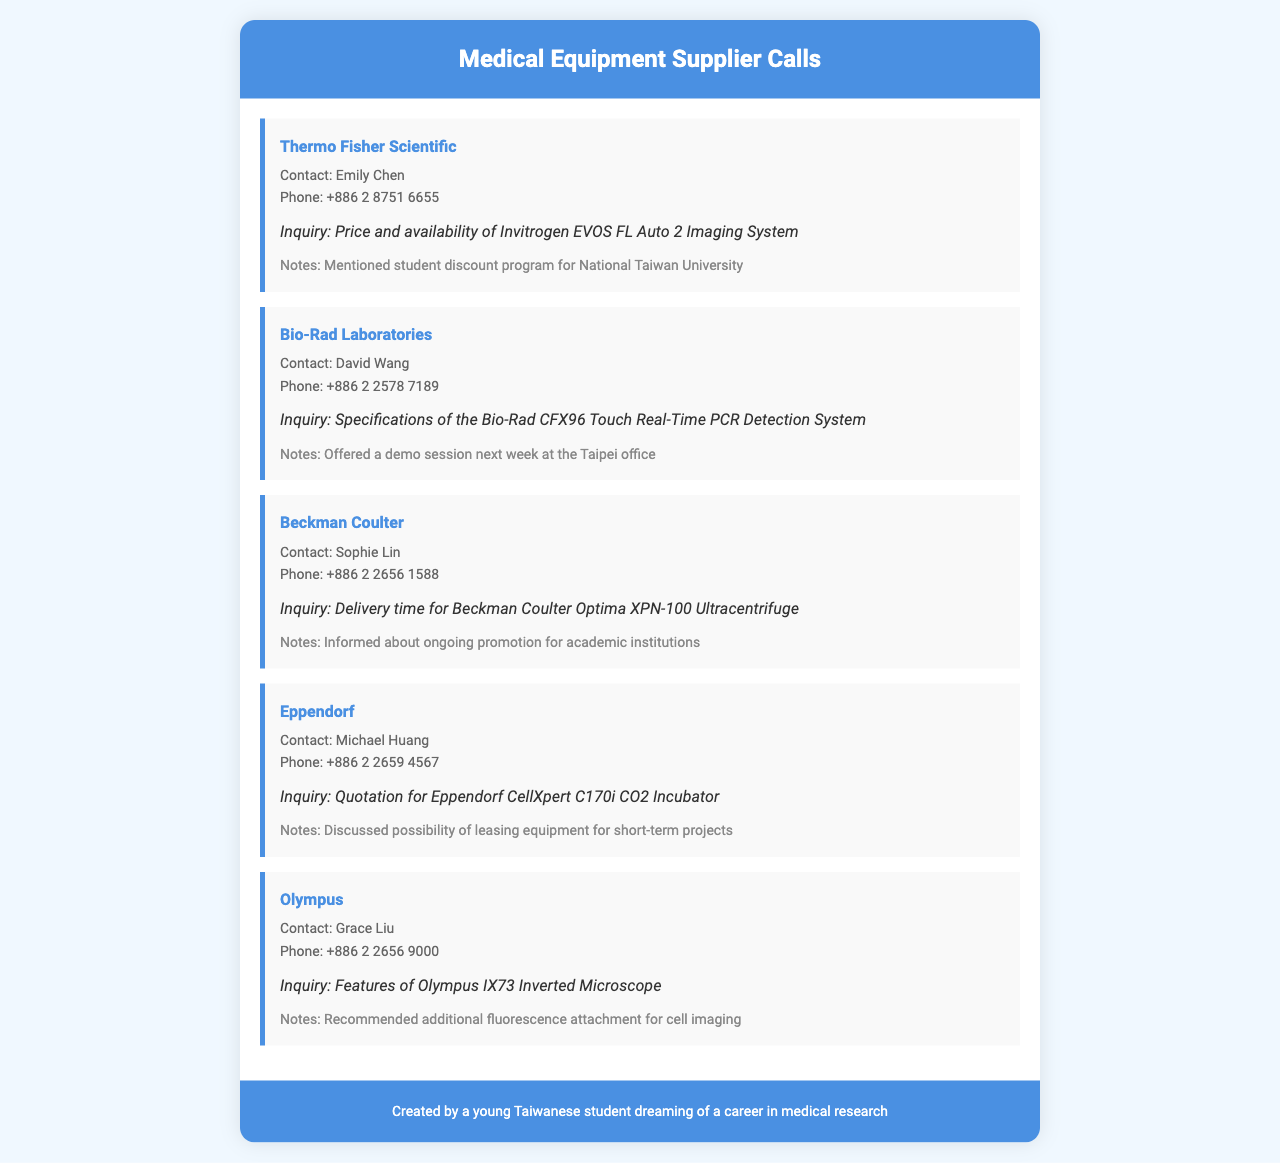What is the company that supplies the Invitrogen EVOS FL Auto 2 Imaging System? The document lists Thermo Fisher Scientific as the supplier for the Invitrogen EVOS FL Auto 2 Imaging System.
Answer: Thermo Fisher Scientific Who is the contact person at Bio-Rad Laboratories? The contact person mentioned for Bio-Rad Laboratories is David Wang.
Answer: David Wang What is the inquiry made to Beckman Coulter? The inquiry to Beckman Coulter is about the delivery time for the Beckman Coulter Optima XPN-100 Ultracentrifuge.
Answer: Delivery time for Beckman Coulter Optima XPN-100 Ultracentrifuge Which supplier offers a student discount program? Thermo Fisher Scientific is noted as offering a student discount program for National Taiwan University.
Answer: Thermo Fisher Scientific How many suppliers were contacted according to the document? The document contains call records from five different medical equipment suppliers.
Answer: Five 